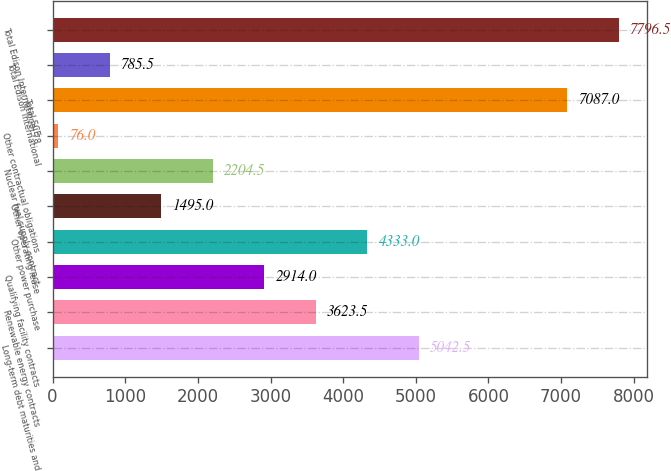Convert chart to OTSL. <chart><loc_0><loc_0><loc_500><loc_500><bar_chart><fcel>Long-term debt maturities and<fcel>Renewable energy contracts<fcel>Qualifying facility contracts<fcel>Other power purchase<fcel>Other operating lease<fcel>Nuclear fuel supply contract<fcel>Other contractual obligations<fcel>Total SCE<fcel>Total Edison International<fcel>Total Edison International 78<nl><fcel>5042.5<fcel>3623.5<fcel>2914<fcel>4333<fcel>1495<fcel>2204.5<fcel>76<fcel>7087<fcel>785.5<fcel>7796.5<nl></chart> 